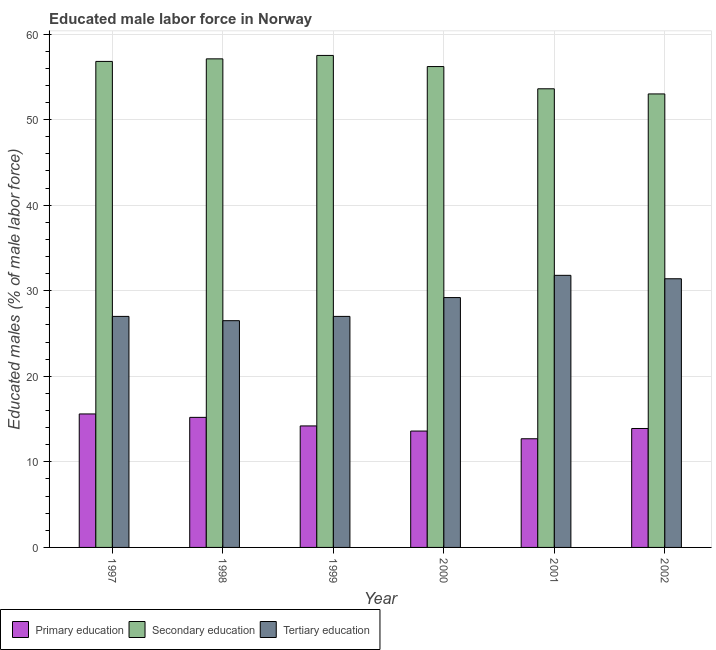How many different coloured bars are there?
Provide a short and direct response. 3. Are the number of bars on each tick of the X-axis equal?
Give a very brief answer. Yes. How many bars are there on the 3rd tick from the left?
Your answer should be compact. 3. In how many cases, is the number of bars for a given year not equal to the number of legend labels?
Offer a very short reply. 0. What is the percentage of male labor force who received secondary education in 2002?
Keep it short and to the point. 53. Across all years, what is the maximum percentage of male labor force who received primary education?
Your answer should be very brief. 15.6. What is the total percentage of male labor force who received primary education in the graph?
Keep it short and to the point. 85.2. What is the difference between the percentage of male labor force who received tertiary education in 1997 and that in 2002?
Your answer should be very brief. -4.4. What is the difference between the percentage of male labor force who received tertiary education in 2000 and the percentage of male labor force who received primary education in 1998?
Keep it short and to the point. 2.7. What is the average percentage of male labor force who received secondary education per year?
Offer a terse response. 55.7. In the year 1997, what is the difference between the percentage of male labor force who received secondary education and percentage of male labor force who received tertiary education?
Keep it short and to the point. 0. What is the ratio of the percentage of male labor force who received secondary education in 1997 to that in 2002?
Make the answer very short. 1.07. Is the percentage of male labor force who received secondary education in 2001 less than that in 2002?
Your answer should be very brief. No. What is the difference between the highest and the second highest percentage of male labor force who received secondary education?
Your answer should be very brief. 0.4. In how many years, is the percentage of male labor force who received secondary education greater than the average percentage of male labor force who received secondary education taken over all years?
Your response must be concise. 4. What does the 2nd bar from the left in 1998 represents?
Keep it short and to the point. Secondary education. What does the 2nd bar from the right in 1997 represents?
Your response must be concise. Secondary education. Does the graph contain grids?
Give a very brief answer. Yes. How many legend labels are there?
Provide a succinct answer. 3. How are the legend labels stacked?
Give a very brief answer. Horizontal. What is the title of the graph?
Offer a very short reply. Educated male labor force in Norway. What is the label or title of the Y-axis?
Offer a terse response. Educated males (% of male labor force). What is the Educated males (% of male labor force) in Primary education in 1997?
Offer a very short reply. 15.6. What is the Educated males (% of male labor force) in Secondary education in 1997?
Your response must be concise. 56.8. What is the Educated males (% of male labor force) in Tertiary education in 1997?
Make the answer very short. 27. What is the Educated males (% of male labor force) of Primary education in 1998?
Provide a succinct answer. 15.2. What is the Educated males (% of male labor force) of Secondary education in 1998?
Your answer should be compact. 57.1. What is the Educated males (% of male labor force) of Tertiary education in 1998?
Make the answer very short. 26.5. What is the Educated males (% of male labor force) of Primary education in 1999?
Keep it short and to the point. 14.2. What is the Educated males (% of male labor force) in Secondary education in 1999?
Provide a succinct answer. 57.5. What is the Educated males (% of male labor force) of Primary education in 2000?
Your answer should be very brief. 13.6. What is the Educated males (% of male labor force) in Secondary education in 2000?
Give a very brief answer. 56.2. What is the Educated males (% of male labor force) of Tertiary education in 2000?
Make the answer very short. 29.2. What is the Educated males (% of male labor force) of Primary education in 2001?
Provide a succinct answer. 12.7. What is the Educated males (% of male labor force) in Secondary education in 2001?
Ensure brevity in your answer.  53.6. What is the Educated males (% of male labor force) in Tertiary education in 2001?
Provide a short and direct response. 31.8. What is the Educated males (% of male labor force) of Primary education in 2002?
Provide a short and direct response. 13.9. What is the Educated males (% of male labor force) in Tertiary education in 2002?
Ensure brevity in your answer.  31.4. Across all years, what is the maximum Educated males (% of male labor force) in Primary education?
Give a very brief answer. 15.6. Across all years, what is the maximum Educated males (% of male labor force) of Secondary education?
Provide a short and direct response. 57.5. Across all years, what is the maximum Educated males (% of male labor force) of Tertiary education?
Ensure brevity in your answer.  31.8. Across all years, what is the minimum Educated males (% of male labor force) of Primary education?
Provide a short and direct response. 12.7. Across all years, what is the minimum Educated males (% of male labor force) in Tertiary education?
Ensure brevity in your answer.  26.5. What is the total Educated males (% of male labor force) in Primary education in the graph?
Offer a very short reply. 85.2. What is the total Educated males (% of male labor force) of Secondary education in the graph?
Keep it short and to the point. 334.2. What is the total Educated males (% of male labor force) of Tertiary education in the graph?
Offer a terse response. 172.9. What is the difference between the Educated males (% of male labor force) in Primary education in 1997 and that in 1998?
Your answer should be very brief. 0.4. What is the difference between the Educated males (% of male labor force) of Secondary education in 1997 and that in 1998?
Give a very brief answer. -0.3. What is the difference between the Educated males (% of male labor force) of Primary education in 1997 and that in 1999?
Your answer should be compact. 1.4. What is the difference between the Educated males (% of male labor force) of Secondary education in 1997 and that in 1999?
Provide a short and direct response. -0.7. What is the difference between the Educated males (% of male labor force) of Primary education in 1997 and that in 2000?
Provide a short and direct response. 2. What is the difference between the Educated males (% of male labor force) in Secondary education in 1997 and that in 2001?
Provide a succinct answer. 3.2. What is the difference between the Educated males (% of male labor force) of Tertiary education in 1997 and that in 2001?
Provide a short and direct response. -4.8. What is the difference between the Educated males (% of male labor force) in Tertiary education in 1997 and that in 2002?
Your response must be concise. -4.4. What is the difference between the Educated males (% of male labor force) of Tertiary education in 1998 and that in 2000?
Make the answer very short. -2.7. What is the difference between the Educated males (% of male labor force) of Primary education in 1998 and that in 2001?
Make the answer very short. 2.5. What is the difference between the Educated males (% of male labor force) of Secondary education in 1998 and that in 2001?
Offer a very short reply. 3.5. What is the difference between the Educated males (% of male labor force) of Tertiary education in 1998 and that in 2001?
Provide a short and direct response. -5.3. What is the difference between the Educated males (% of male labor force) in Tertiary education in 1998 and that in 2002?
Offer a very short reply. -4.9. What is the difference between the Educated males (% of male labor force) in Tertiary education in 1999 and that in 2000?
Your answer should be very brief. -2.2. What is the difference between the Educated males (% of male labor force) of Primary education in 1999 and that in 2001?
Ensure brevity in your answer.  1.5. What is the difference between the Educated males (% of male labor force) in Secondary education in 1999 and that in 2002?
Give a very brief answer. 4.5. What is the difference between the Educated males (% of male labor force) in Primary education in 2000 and that in 2002?
Provide a short and direct response. -0.3. What is the difference between the Educated males (% of male labor force) of Tertiary education in 2000 and that in 2002?
Make the answer very short. -2.2. What is the difference between the Educated males (% of male labor force) of Primary education in 1997 and the Educated males (% of male labor force) of Secondary education in 1998?
Make the answer very short. -41.5. What is the difference between the Educated males (% of male labor force) of Primary education in 1997 and the Educated males (% of male labor force) of Tertiary education in 1998?
Offer a terse response. -10.9. What is the difference between the Educated males (% of male labor force) of Secondary education in 1997 and the Educated males (% of male labor force) of Tertiary education in 1998?
Offer a very short reply. 30.3. What is the difference between the Educated males (% of male labor force) in Primary education in 1997 and the Educated males (% of male labor force) in Secondary education in 1999?
Provide a succinct answer. -41.9. What is the difference between the Educated males (% of male labor force) of Secondary education in 1997 and the Educated males (% of male labor force) of Tertiary education in 1999?
Provide a short and direct response. 29.8. What is the difference between the Educated males (% of male labor force) in Primary education in 1997 and the Educated males (% of male labor force) in Secondary education in 2000?
Offer a terse response. -40.6. What is the difference between the Educated males (% of male labor force) in Secondary education in 1997 and the Educated males (% of male labor force) in Tertiary education in 2000?
Keep it short and to the point. 27.6. What is the difference between the Educated males (% of male labor force) of Primary education in 1997 and the Educated males (% of male labor force) of Secondary education in 2001?
Give a very brief answer. -38. What is the difference between the Educated males (% of male labor force) of Primary education in 1997 and the Educated males (% of male labor force) of Tertiary education in 2001?
Your answer should be compact. -16.2. What is the difference between the Educated males (% of male labor force) in Primary education in 1997 and the Educated males (% of male labor force) in Secondary education in 2002?
Provide a succinct answer. -37.4. What is the difference between the Educated males (% of male labor force) of Primary education in 1997 and the Educated males (% of male labor force) of Tertiary education in 2002?
Your answer should be compact. -15.8. What is the difference between the Educated males (% of male labor force) in Secondary education in 1997 and the Educated males (% of male labor force) in Tertiary education in 2002?
Your response must be concise. 25.4. What is the difference between the Educated males (% of male labor force) in Primary education in 1998 and the Educated males (% of male labor force) in Secondary education in 1999?
Your answer should be compact. -42.3. What is the difference between the Educated males (% of male labor force) in Primary education in 1998 and the Educated males (% of male labor force) in Tertiary education in 1999?
Give a very brief answer. -11.8. What is the difference between the Educated males (% of male labor force) of Secondary education in 1998 and the Educated males (% of male labor force) of Tertiary education in 1999?
Offer a very short reply. 30.1. What is the difference between the Educated males (% of male labor force) of Primary education in 1998 and the Educated males (% of male labor force) of Secondary education in 2000?
Offer a very short reply. -41. What is the difference between the Educated males (% of male labor force) of Primary education in 1998 and the Educated males (% of male labor force) of Tertiary education in 2000?
Offer a terse response. -14. What is the difference between the Educated males (% of male labor force) of Secondary education in 1998 and the Educated males (% of male labor force) of Tertiary education in 2000?
Keep it short and to the point. 27.9. What is the difference between the Educated males (% of male labor force) of Primary education in 1998 and the Educated males (% of male labor force) of Secondary education in 2001?
Offer a very short reply. -38.4. What is the difference between the Educated males (% of male labor force) of Primary education in 1998 and the Educated males (% of male labor force) of Tertiary education in 2001?
Make the answer very short. -16.6. What is the difference between the Educated males (% of male labor force) of Secondary education in 1998 and the Educated males (% of male labor force) of Tertiary education in 2001?
Provide a short and direct response. 25.3. What is the difference between the Educated males (% of male labor force) in Primary education in 1998 and the Educated males (% of male labor force) in Secondary education in 2002?
Provide a succinct answer. -37.8. What is the difference between the Educated males (% of male labor force) in Primary education in 1998 and the Educated males (% of male labor force) in Tertiary education in 2002?
Provide a succinct answer. -16.2. What is the difference between the Educated males (% of male labor force) of Secondary education in 1998 and the Educated males (% of male labor force) of Tertiary education in 2002?
Keep it short and to the point. 25.7. What is the difference between the Educated males (% of male labor force) in Primary education in 1999 and the Educated males (% of male labor force) in Secondary education in 2000?
Your answer should be compact. -42. What is the difference between the Educated males (% of male labor force) of Primary education in 1999 and the Educated males (% of male labor force) of Tertiary education in 2000?
Your response must be concise. -15. What is the difference between the Educated males (% of male labor force) of Secondary education in 1999 and the Educated males (% of male labor force) of Tertiary education in 2000?
Offer a very short reply. 28.3. What is the difference between the Educated males (% of male labor force) of Primary education in 1999 and the Educated males (% of male labor force) of Secondary education in 2001?
Your answer should be compact. -39.4. What is the difference between the Educated males (% of male labor force) of Primary education in 1999 and the Educated males (% of male labor force) of Tertiary education in 2001?
Provide a succinct answer. -17.6. What is the difference between the Educated males (% of male labor force) in Secondary education in 1999 and the Educated males (% of male labor force) in Tertiary education in 2001?
Offer a terse response. 25.7. What is the difference between the Educated males (% of male labor force) of Primary education in 1999 and the Educated males (% of male labor force) of Secondary education in 2002?
Offer a terse response. -38.8. What is the difference between the Educated males (% of male labor force) in Primary education in 1999 and the Educated males (% of male labor force) in Tertiary education in 2002?
Provide a short and direct response. -17.2. What is the difference between the Educated males (% of male labor force) of Secondary education in 1999 and the Educated males (% of male labor force) of Tertiary education in 2002?
Give a very brief answer. 26.1. What is the difference between the Educated males (% of male labor force) of Primary education in 2000 and the Educated males (% of male labor force) of Tertiary education in 2001?
Give a very brief answer. -18.2. What is the difference between the Educated males (% of male labor force) of Secondary education in 2000 and the Educated males (% of male labor force) of Tertiary education in 2001?
Offer a very short reply. 24.4. What is the difference between the Educated males (% of male labor force) of Primary education in 2000 and the Educated males (% of male labor force) of Secondary education in 2002?
Your answer should be very brief. -39.4. What is the difference between the Educated males (% of male labor force) in Primary education in 2000 and the Educated males (% of male labor force) in Tertiary education in 2002?
Your answer should be very brief. -17.8. What is the difference between the Educated males (% of male labor force) of Secondary education in 2000 and the Educated males (% of male labor force) of Tertiary education in 2002?
Your response must be concise. 24.8. What is the difference between the Educated males (% of male labor force) of Primary education in 2001 and the Educated males (% of male labor force) of Secondary education in 2002?
Make the answer very short. -40.3. What is the difference between the Educated males (% of male labor force) in Primary education in 2001 and the Educated males (% of male labor force) in Tertiary education in 2002?
Keep it short and to the point. -18.7. What is the average Educated males (% of male labor force) in Primary education per year?
Offer a terse response. 14.2. What is the average Educated males (% of male labor force) in Secondary education per year?
Give a very brief answer. 55.7. What is the average Educated males (% of male labor force) of Tertiary education per year?
Offer a very short reply. 28.82. In the year 1997, what is the difference between the Educated males (% of male labor force) in Primary education and Educated males (% of male labor force) in Secondary education?
Keep it short and to the point. -41.2. In the year 1997, what is the difference between the Educated males (% of male labor force) of Primary education and Educated males (% of male labor force) of Tertiary education?
Give a very brief answer. -11.4. In the year 1997, what is the difference between the Educated males (% of male labor force) of Secondary education and Educated males (% of male labor force) of Tertiary education?
Your response must be concise. 29.8. In the year 1998, what is the difference between the Educated males (% of male labor force) of Primary education and Educated males (% of male labor force) of Secondary education?
Your answer should be very brief. -41.9. In the year 1998, what is the difference between the Educated males (% of male labor force) of Primary education and Educated males (% of male labor force) of Tertiary education?
Give a very brief answer. -11.3. In the year 1998, what is the difference between the Educated males (% of male labor force) of Secondary education and Educated males (% of male labor force) of Tertiary education?
Keep it short and to the point. 30.6. In the year 1999, what is the difference between the Educated males (% of male labor force) in Primary education and Educated males (% of male labor force) in Secondary education?
Your answer should be compact. -43.3. In the year 1999, what is the difference between the Educated males (% of male labor force) of Primary education and Educated males (% of male labor force) of Tertiary education?
Your answer should be compact. -12.8. In the year 1999, what is the difference between the Educated males (% of male labor force) in Secondary education and Educated males (% of male labor force) in Tertiary education?
Provide a succinct answer. 30.5. In the year 2000, what is the difference between the Educated males (% of male labor force) of Primary education and Educated males (% of male labor force) of Secondary education?
Provide a succinct answer. -42.6. In the year 2000, what is the difference between the Educated males (% of male labor force) of Primary education and Educated males (% of male labor force) of Tertiary education?
Provide a short and direct response. -15.6. In the year 2001, what is the difference between the Educated males (% of male labor force) of Primary education and Educated males (% of male labor force) of Secondary education?
Keep it short and to the point. -40.9. In the year 2001, what is the difference between the Educated males (% of male labor force) of Primary education and Educated males (% of male labor force) of Tertiary education?
Your answer should be compact. -19.1. In the year 2001, what is the difference between the Educated males (% of male labor force) in Secondary education and Educated males (% of male labor force) in Tertiary education?
Offer a terse response. 21.8. In the year 2002, what is the difference between the Educated males (% of male labor force) of Primary education and Educated males (% of male labor force) of Secondary education?
Keep it short and to the point. -39.1. In the year 2002, what is the difference between the Educated males (% of male labor force) of Primary education and Educated males (% of male labor force) of Tertiary education?
Your answer should be compact. -17.5. In the year 2002, what is the difference between the Educated males (% of male labor force) of Secondary education and Educated males (% of male labor force) of Tertiary education?
Provide a succinct answer. 21.6. What is the ratio of the Educated males (% of male labor force) in Primary education in 1997 to that in 1998?
Give a very brief answer. 1.03. What is the ratio of the Educated males (% of male labor force) in Secondary education in 1997 to that in 1998?
Keep it short and to the point. 0.99. What is the ratio of the Educated males (% of male labor force) in Tertiary education in 1997 to that in 1998?
Keep it short and to the point. 1.02. What is the ratio of the Educated males (% of male labor force) of Primary education in 1997 to that in 1999?
Keep it short and to the point. 1.1. What is the ratio of the Educated males (% of male labor force) in Secondary education in 1997 to that in 1999?
Provide a succinct answer. 0.99. What is the ratio of the Educated males (% of male labor force) of Primary education in 1997 to that in 2000?
Provide a succinct answer. 1.15. What is the ratio of the Educated males (% of male labor force) of Secondary education in 1997 to that in 2000?
Your answer should be compact. 1.01. What is the ratio of the Educated males (% of male labor force) of Tertiary education in 1997 to that in 2000?
Your answer should be compact. 0.92. What is the ratio of the Educated males (% of male labor force) in Primary education in 1997 to that in 2001?
Keep it short and to the point. 1.23. What is the ratio of the Educated males (% of male labor force) of Secondary education in 1997 to that in 2001?
Your answer should be very brief. 1.06. What is the ratio of the Educated males (% of male labor force) in Tertiary education in 1997 to that in 2001?
Ensure brevity in your answer.  0.85. What is the ratio of the Educated males (% of male labor force) of Primary education in 1997 to that in 2002?
Offer a terse response. 1.12. What is the ratio of the Educated males (% of male labor force) of Secondary education in 1997 to that in 2002?
Keep it short and to the point. 1.07. What is the ratio of the Educated males (% of male labor force) in Tertiary education in 1997 to that in 2002?
Offer a terse response. 0.86. What is the ratio of the Educated males (% of male labor force) of Primary education in 1998 to that in 1999?
Make the answer very short. 1.07. What is the ratio of the Educated males (% of male labor force) of Tertiary education in 1998 to that in 1999?
Give a very brief answer. 0.98. What is the ratio of the Educated males (% of male labor force) in Primary education in 1998 to that in 2000?
Provide a short and direct response. 1.12. What is the ratio of the Educated males (% of male labor force) of Secondary education in 1998 to that in 2000?
Provide a short and direct response. 1.02. What is the ratio of the Educated males (% of male labor force) of Tertiary education in 1998 to that in 2000?
Your answer should be compact. 0.91. What is the ratio of the Educated males (% of male labor force) in Primary education in 1998 to that in 2001?
Your answer should be very brief. 1.2. What is the ratio of the Educated males (% of male labor force) in Secondary education in 1998 to that in 2001?
Ensure brevity in your answer.  1.07. What is the ratio of the Educated males (% of male labor force) of Tertiary education in 1998 to that in 2001?
Make the answer very short. 0.83. What is the ratio of the Educated males (% of male labor force) in Primary education in 1998 to that in 2002?
Keep it short and to the point. 1.09. What is the ratio of the Educated males (% of male labor force) of Secondary education in 1998 to that in 2002?
Provide a succinct answer. 1.08. What is the ratio of the Educated males (% of male labor force) in Tertiary education in 1998 to that in 2002?
Provide a succinct answer. 0.84. What is the ratio of the Educated males (% of male labor force) of Primary education in 1999 to that in 2000?
Give a very brief answer. 1.04. What is the ratio of the Educated males (% of male labor force) in Secondary education in 1999 to that in 2000?
Provide a short and direct response. 1.02. What is the ratio of the Educated males (% of male labor force) in Tertiary education in 1999 to that in 2000?
Your answer should be very brief. 0.92. What is the ratio of the Educated males (% of male labor force) of Primary education in 1999 to that in 2001?
Make the answer very short. 1.12. What is the ratio of the Educated males (% of male labor force) of Secondary education in 1999 to that in 2001?
Offer a very short reply. 1.07. What is the ratio of the Educated males (% of male labor force) of Tertiary education in 1999 to that in 2001?
Your response must be concise. 0.85. What is the ratio of the Educated males (% of male labor force) in Primary education in 1999 to that in 2002?
Provide a succinct answer. 1.02. What is the ratio of the Educated males (% of male labor force) of Secondary education in 1999 to that in 2002?
Keep it short and to the point. 1.08. What is the ratio of the Educated males (% of male labor force) of Tertiary education in 1999 to that in 2002?
Offer a very short reply. 0.86. What is the ratio of the Educated males (% of male labor force) of Primary education in 2000 to that in 2001?
Make the answer very short. 1.07. What is the ratio of the Educated males (% of male labor force) of Secondary education in 2000 to that in 2001?
Provide a short and direct response. 1.05. What is the ratio of the Educated males (% of male labor force) of Tertiary education in 2000 to that in 2001?
Your response must be concise. 0.92. What is the ratio of the Educated males (% of male labor force) in Primary education in 2000 to that in 2002?
Keep it short and to the point. 0.98. What is the ratio of the Educated males (% of male labor force) of Secondary education in 2000 to that in 2002?
Make the answer very short. 1.06. What is the ratio of the Educated males (% of male labor force) in Tertiary education in 2000 to that in 2002?
Keep it short and to the point. 0.93. What is the ratio of the Educated males (% of male labor force) of Primary education in 2001 to that in 2002?
Offer a very short reply. 0.91. What is the ratio of the Educated males (% of male labor force) in Secondary education in 2001 to that in 2002?
Your answer should be compact. 1.01. What is the ratio of the Educated males (% of male labor force) of Tertiary education in 2001 to that in 2002?
Offer a terse response. 1.01. What is the difference between the highest and the second highest Educated males (% of male labor force) of Primary education?
Your answer should be very brief. 0.4. What is the difference between the highest and the second highest Educated males (% of male labor force) in Secondary education?
Your answer should be very brief. 0.4. What is the difference between the highest and the second highest Educated males (% of male labor force) of Tertiary education?
Provide a succinct answer. 0.4. What is the difference between the highest and the lowest Educated males (% of male labor force) of Secondary education?
Offer a very short reply. 4.5. What is the difference between the highest and the lowest Educated males (% of male labor force) in Tertiary education?
Your response must be concise. 5.3. 